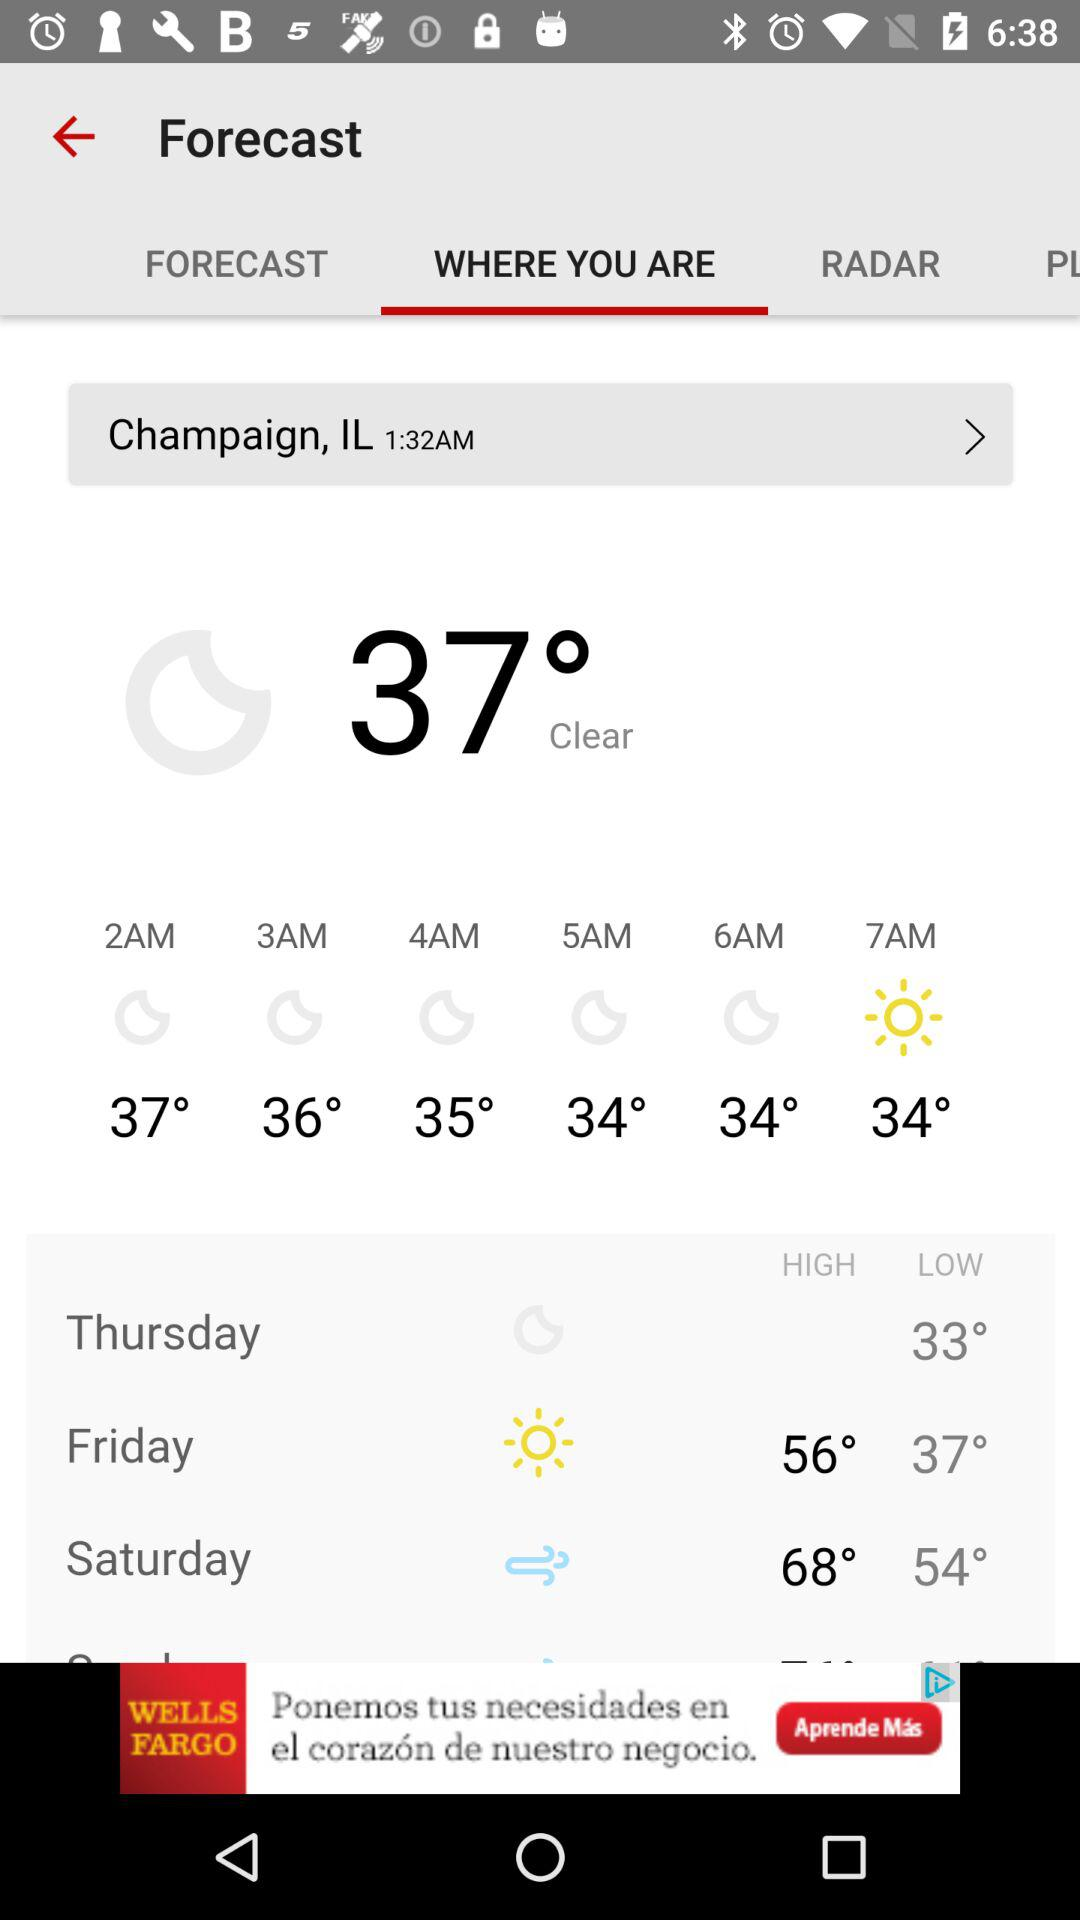What is the temperature at 7 a.m.? The temperature is 34°. 